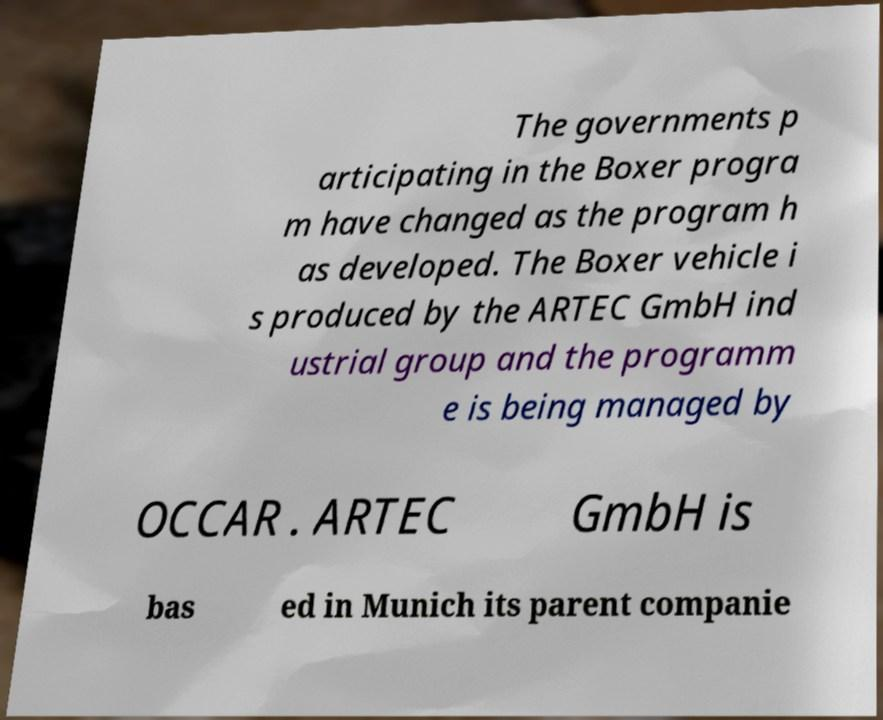I need the written content from this picture converted into text. Can you do that? The governments p articipating in the Boxer progra m have changed as the program h as developed. The Boxer vehicle i s produced by the ARTEC GmbH ind ustrial group and the programm e is being managed by OCCAR . ARTEC GmbH is bas ed in Munich its parent companie 